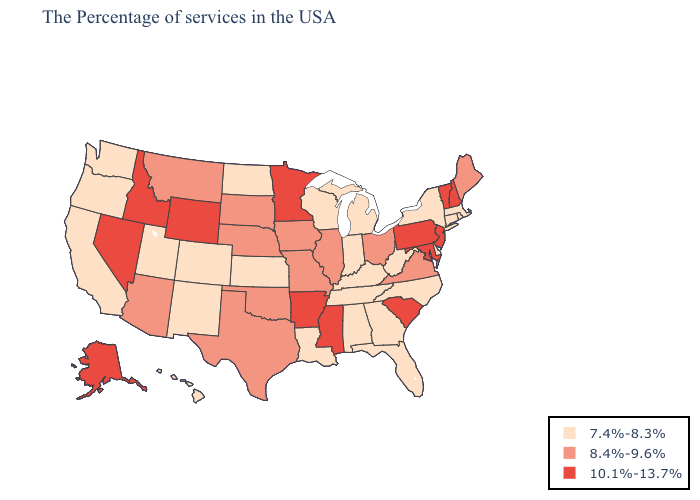Does the first symbol in the legend represent the smallest category?
Quick response, please. Yes. Among the states that border North Dakota , does Montana have the lowest value?
Concise answer only. Yes. Name the states that have a value in the range 8.4%-9.6%?
Answer briefly. Maine, Virginia, Ohio, Illinois, Missouri, Iowa, Nebraska, Oklahoma, Texas, South Dakota, Montana, Arizona. Among the states that border Kentucky , which have the highest value?
Quick response, please. Virginia, Ohio, Illinois, Missouri. Name the states that have a value in the range 10.1%-13.7%?
Write a very short answer. New Hampshire, Vermont, New Jersey, Maryland, Pennsylvania, South Carolina, Mississippi, Arkansas, Minnesota, Wyoming, Idaho, Nevada, Alaska. Does Rhode Island have the same value as Missouri?
Write a very short answer. No. Among the states that border Illinois , which have the lowest value?
Be succinct. Kentucky, Indiana, Wisconsin. Which states have the lowest value in the West?
Give a very brief answer. Colorado, New Mexico, Utah, California, Washington, Oregon, Hawaii. What is the highest value in the West ?
Write a very short answer. 10.1%-13.7%. Does the map have missing data?
Give a very brief answer. No. Does Oklahoma have the highest value in the USA?
Answer briefly. No. Which states hav the highest value in the MidWest?
Write a very short answer. Minnesota. Does New York have the same value as Texas?
Write a very short answer. No. What is the value of Idaho?
Quick response, please. 10.1%-13.7%. What is the value of Vermont?
Short answer required. 10.1%-13.7%. 